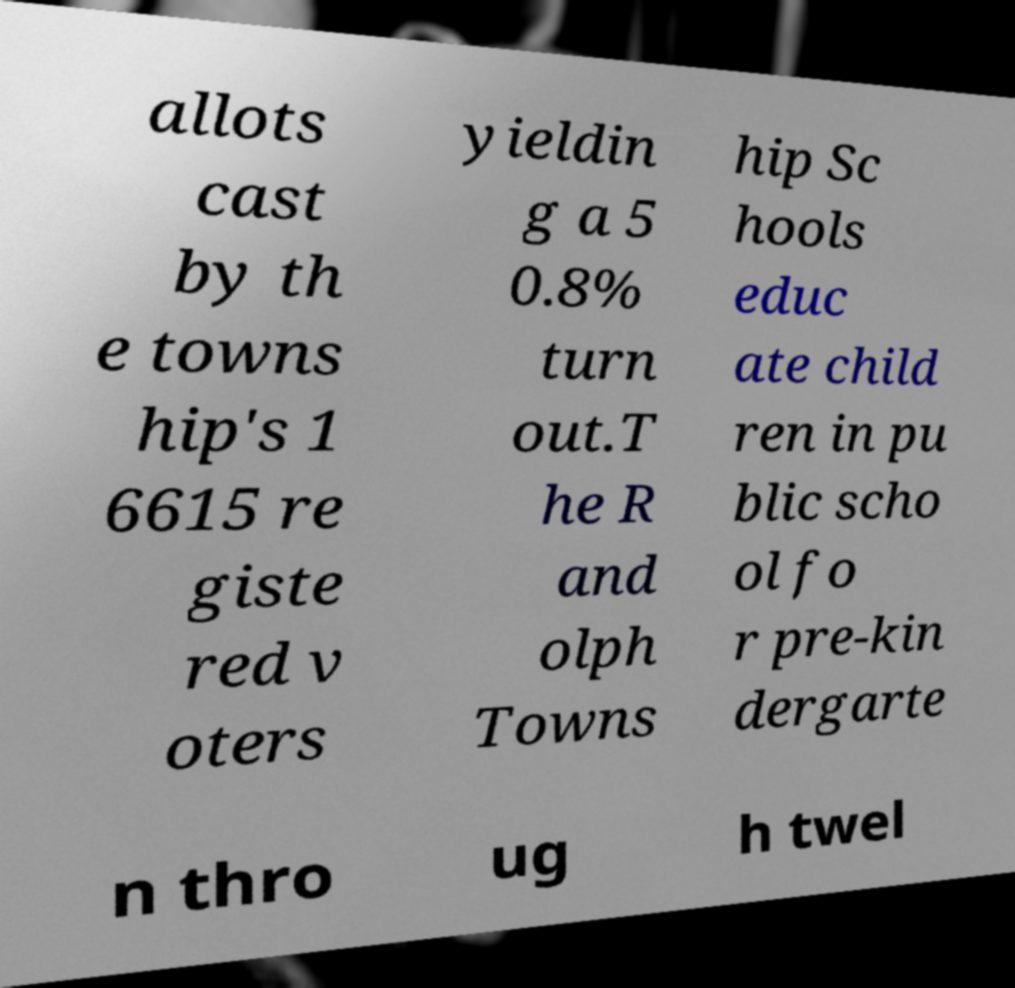Please read and relay the text visible in this image. What does it say? allots cast by th e towns hip's 1 6615 re giste red v oters yieldin g a 5 0.8% turn out.T he R and olph Towns hip Sc hools educ ate child ren in pu blic scho ol fo r pre-kin dergarte n thro ug h twel 